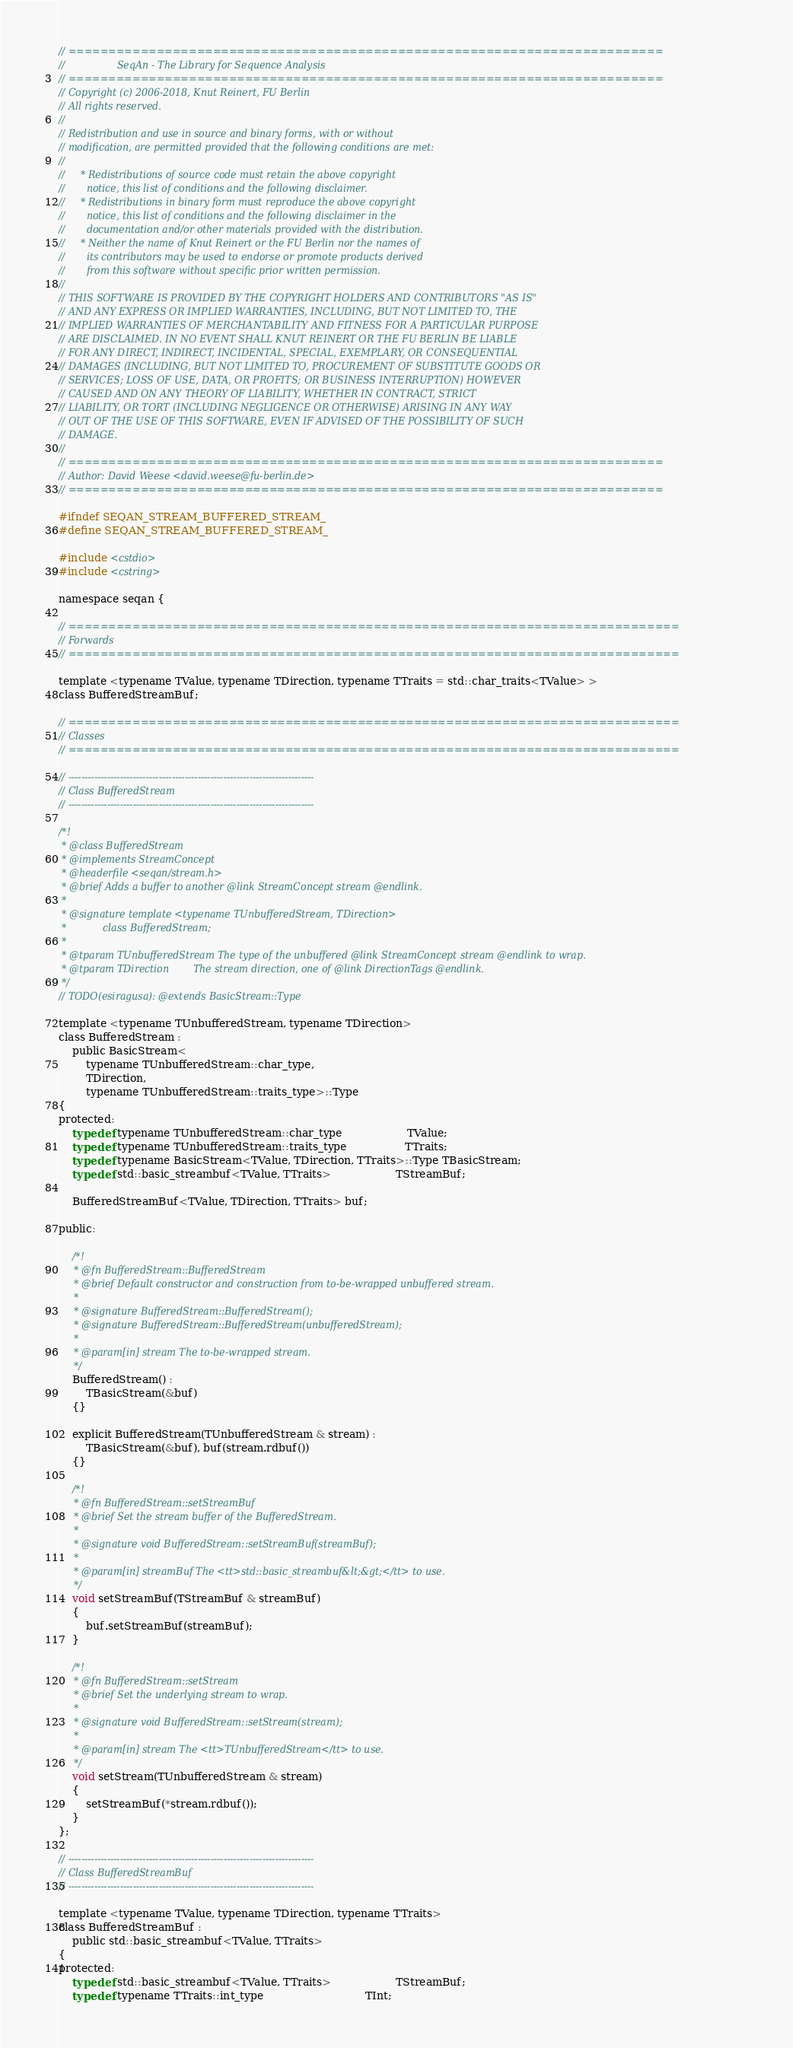Convert code to text. <code><loc_0><loc_0><loc_500><loc_500><_C_>// ==========================================================================
//                 SeqAn - The Library for Sequence Analysis
// ==========================================================================
// Copyright (c) 2006-2018, Knut Reinert, FU Berlin
// All rights reserved.
//
// Redistribution and use in source and binary forms, with or without
// modification, are permitted provided that the following conditions are met:
//
//     * Redistributions of source code must retain the above copyright
//       notice, this list of conditions and the following disclaimer.
//     * Redistributions in binary form must reproduce the above copyright
//       notice, this list of conditions and the following disclaimer in the
//       documentation and/or other materials provided with the distribution.
//     * Neither the name of Knut Reinert or the FU Berlin nor the names of
//       its contributors may be used to endorse or promote products derived
//       from this software without specific prior written permission.
//
// THIS SOFTWARE IS PROVIDED BY THE COPYRIGHT HOLDERS AND CONTRIBUTORS "AS IS"
// AND ANY EXPRESS OR IMPLIED WARRANTIES, INCLUDING, BUT NOT LIMITED TO, THE
// IMPLIED WARRANTIES OF MERCHANTABILITY AND FITNESS FOR A PARTICULAR PURPOSE
// ARE DISCLAIMED. IN NO EVENT SHALL KNUT REINERT OR THE FU BERLIN BE LIABLE
// FOR ANY DIRECT, INDIRECT, INCIDENTAL, SPECIAL, EXEMPLARY, OR CONSEQUENTIAL
// DAMAGES (INCLUDING, BUT NOT LIMITED TO, PROCUREMENT OF SUBSTITUTE GOODS OR
// SERVICES; LOSS OF USE, DATA, OR PROFITS; OR BUSINESS INTERRUPTION) HOWEVER
// CAUSED AND ON ANY THEORY OF LIABILITY, WHETHER IN CONTRACT, STRICT
// LIABILITY, OR TORT (INCLUDING NEGLIGENCE OR OTHERWISE) ARISING IN ANY WAY
// OUT OF THE USE OF THIS SOFTWARE, EVEN IF ADVISED OF THE POSSIBILITY OF SUCH
// DAMAGE.
//
// ==========================================================================
// Author: David Weese <david.weese@fu-berlin.de>
// ==========================================================================

#ifndef SEQAN_STREAM_BUFFERED_STREAM_
#define SEQAN_STREAM_BUFFERED_STREAM_

#include <cstdio>
#include <cstring>

namespace seqan {

// ============================================================================
// Forwards
// ============================================================================

template <typename TValue, typename TDirection, typename TTraits = std::char_traits<TValue> >
class BufferedStreamBuf;

// ============================================================================
// Classes
// ============================================================================

// ----------------------------------------------------------------------------
// Class BufferedStream
// ----------------------------------------------------------------------------

/*!
 * @class BufferedStream
 * @implements StreamConcept
 * @headerfile <seqan/stream.h>
 * @brief Adds a buffer to another @link StreamConcept stream @endlink.
 *
 * @signature template <typename TUnbufferedStream, TDirection>
 *            class BufferedStream;
 *
 * @tparam TUnbufferedStream The type of the unbuffered @link StreamConcept stream @endlink to wrap.
 * @tparam TDirection        The stream direction, one of @link DirectionTags @endlink.
 */
// TODO(esiragusa): @extends BasicStream::Type

template <typename TUnbufferedStream, typename TDirection>
class BufferedStream :
    public BasicStream<
        typename TUnbufferedStream::char_type,
        TDirection,
        typename TUnbufferedStream::traits_type>::Type
{
protected:
    typedef typename TUnbufferedStream::char_type                   TValue;
    typedef typename TUnbufferedStream::traits_type                 TTraits;
    typedef typename BasicStream<TValue, TDirection, TTraits>::Type TBasicStream;
    typedef std::basic_streambuf<TValue, TTraits>                   TStreamBuf;

    BufferedStreamBuf<TValue, TDirection, TTraits> buf;

public:

    /*!
     * @fn BufferedStream::BufferedStream
     * @brief Default constructor and construction from to-be-wrapped unbuffered stream.
     *
     * @signature BufferedStream::BufferedStream();
     * @signature BufferedStream::BufferedStream(unbufferedStream);
     *
     * @param[in] stream The to-be-wrapped stream.
     */
    BufferedStream() :
        TBasicStream(&buf)
    {}

    explicit BufferedStream(TUnbufferedStream & stream) :
        TBasicStream(&buf), buf(stream.rdbuf())
    {}

    /*!
     * @fn BufferedStream::setStreamBuf
     * @brief Set the stream buffer of the BufferedStream.
     *
     * @signature void BufferedStream::setStreamBuf(streamBuf);
     *
     * @param[in] streamBuf The <tt>std::basic_streambuf&lt;&gt;</tt> to use.
     */
    void setStreamBuf(TStreamBuf & streamBuf)
    {
        buf.setStreamBuf(streamBuf);
    }

    /*!
     * @fn BufferedStream::setStream
     * @brief Set the underlying stream to wrap.
     *
     * @signature void BufferedStream::setStream(stream);
     *
     * @param[in] stream The <tt>TUnbufferedStream</tt> to use.
     */
    void setStream(TUnbufferedStream & stream)
    {
        setStreamBuf(*stream.rdbuf());
    }
};

// ----------------------------------------------------------------------------
// Class BufferedStreamBuf
// ----------------------------------------------------------------------------

template <typename TValue, typename TDirection, typename TTraits>
class BufferedStreamBuf :
    public std::basic_streambuf<TValue, TTraits>
{
protected:
    typedef std::basic_streambuf<TValue, TTraits>                   TStreamBuf;
    typedef typename TTraits::int_type                              TInt;
</code> 